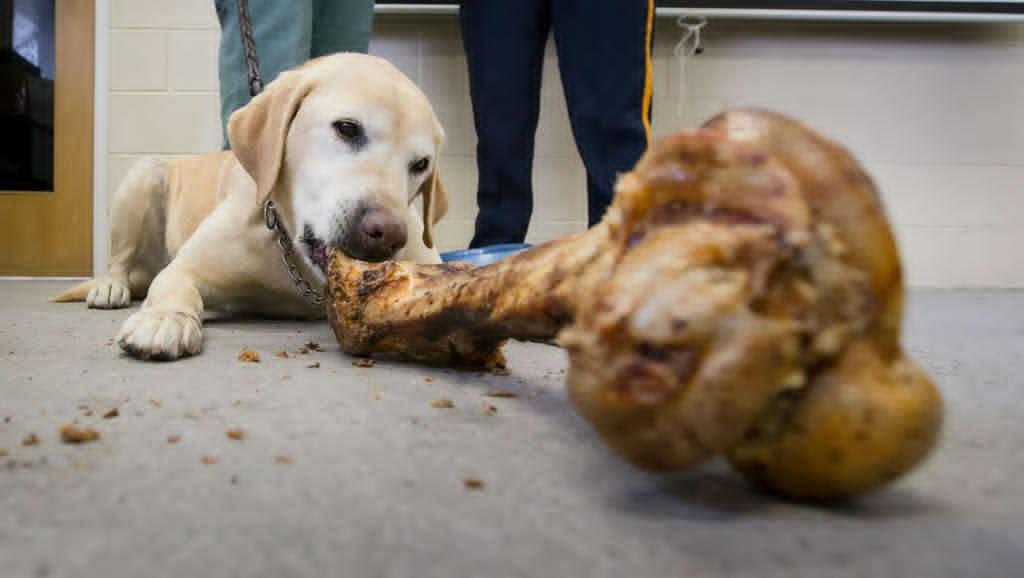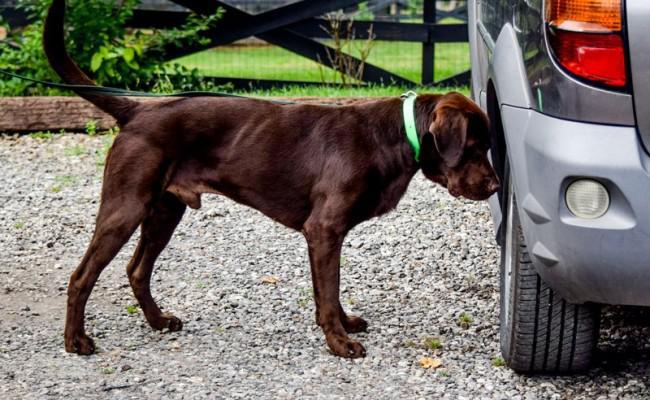The first image is the image on the left, the second image is the image on the right. Assess this claim about the two images: "There is at least 1 black and 1 white dog near some grass.". Correct or not? Answer yes or no. No. 